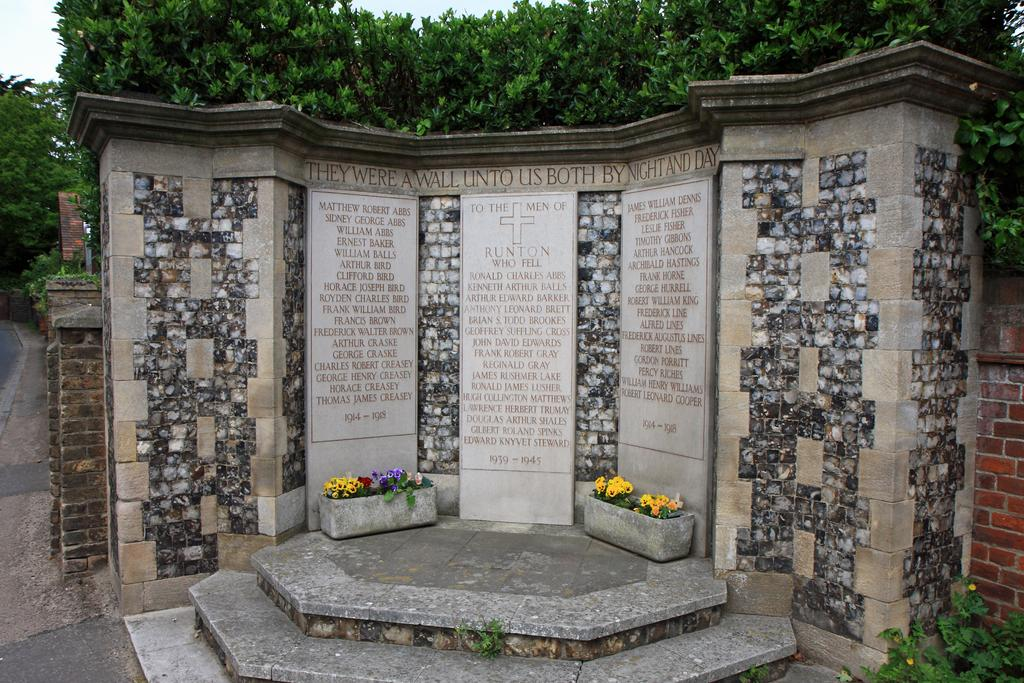What type of structure is visible in the image? There is a stone wall and a brick wall in the image. What can be found on the stone wall? Memorial stones are present on the stone wall. What objects are used for planting in the image? There are flower pots in the image. What type of vegetation is visible in the image? Plants and trees are visible in the image. What is visible in the background of the image? The sky is visible in the background of the image. How much payment is required to enter the area in the image? There is no indication of any payment required to enter the area in the image. What type of birds can be seen flying in the image? There are no birds visible in the image. 